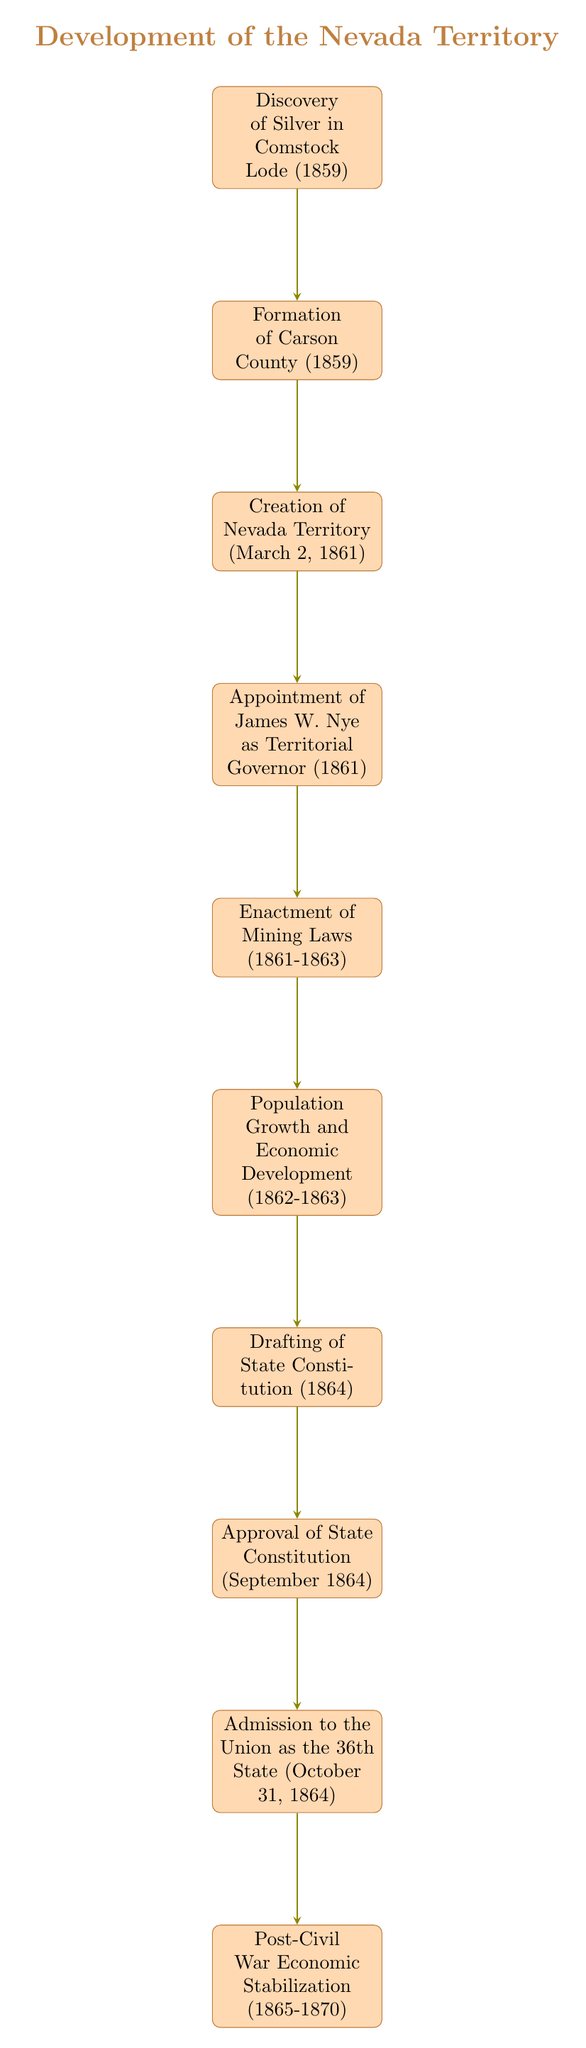What year did the Discovery of Silver in Comstock Lode occur? According to the first node in the diagram, the Discovery of Silver in the Comstock Lode happened in the year 1859.
Answer: 1859 How many major events are illustrated in the flow chart? The flow chart contains a total of 10 nodes, indicating there are 10 major events leading to the development of the Nevada Territory.
Answer: 10 What is the event that directly follows the Formation of Carson County? The node following the Formation of Carson County (1859) is the Creation of the Nevada Territory (March 2, 1861), which directly follows it in the flow of events.
Answer: Creation of Nevada Territory (March 2, 1861) Which event led to the drafting of the State Constitution? The node that leads to the drafting of the State Constitution is Population Growth and Economic Development (1862-1863), as it is the immediate predecessor in the sequence.
Answer: Population Growth and Economic Development (1862-1863) In what month and year was the approval of the State Constitution? The flow chart indicates that the Approval of the State Constitution occurred in September 1864, which can be directly identified from the corresponding node.
Answer: September 1864 How does the approval of the State Constitution relate to Nevada’s admission to the Union? The Approval of the State Constitution (September 1864) is the event that directly precedes Nevada's Admission to the Union as the 36th State (October 31, 1864), implying that the statehood process was initiated following the constitution's approval.
Answer: Directly precedes What major economic stabilization occurred after Nevada's admission to the Union? The diagram shows that after Nevada's Admission to the Union (October 31, 1864), there was a Post-Civil War Economic Stabilization that took place from 1865 to 1870, indicating the economic recovery following statehood.
Answer: Post-Civil War Economic Stabilization What major law was enacted between 1861 and 1863? The event of Enactment of Mining Laws is specified within the timeline in the flow chart as occurring between 1861 and 1863, addressing important legal developments in the territory.
Answer: Enactment of Mining Laws (1861-1863) 